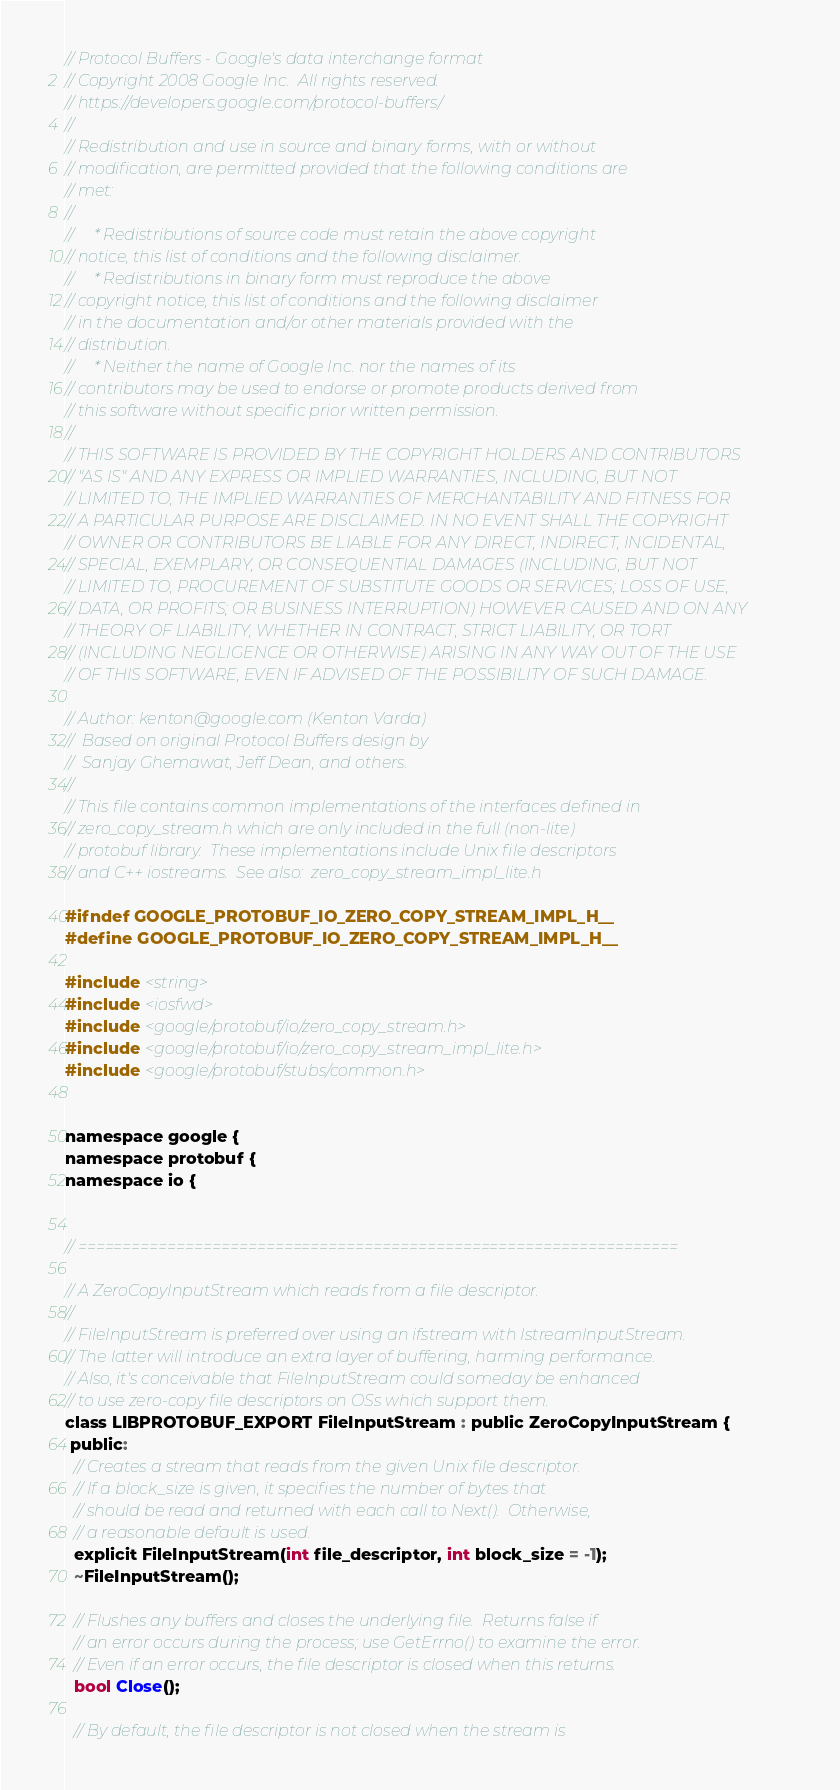<code> <loc_0><loc_0><loc_500><loc_500><_C_>// Protocol Buffers - Google's data interchange format
// Copyright 2008 Google Inc.  All rights reserved.
// https://developers.google.com/protocol-buffers/
//
// Redistribution and use in source and binary forms, with or without
// modification, are permitted provided that the following conditions are
// met:
//
//     * Redistributions of source code must retain the above copyright
// notice, this list of conditions and the following disclaimer.
//     * Redistributions in binary form must reproduce the above
// copyright notice, this list of conditions and the following disclaimer
// in the documentation and/or other materials provided with the
// distribution.
//     * Neither the name of Google Inc. nor the names of its
// contributors may be used to endorse or promote products derived from
// this software without specific prior written permission.
//
// THIS SOFTWARE IS PROVIDED BY THE COPYRIGHT HOLDERS AND CONTRIBUTORS
// "AS IS" AND ANY EXPRESS OR IMPLIED WARRANTIES, INCLUDING, BUT NOT
// LIMITED TO, THE IMPLIED WARRANTIES OF MERCHANTABILITY AND FITNESS FOR
// A PARTICULAR PURPOSE ARE DISCLAIMED. IN NO EVENT SHALL THE COPYRIGHT
// OWNER OR CONTRIBUTORS BE LIABLE FOR ANY DIRECT, INDIRECT, INCIDENTAL,
// SPECIAL, EXEMPLARY, OR CONSEQUENTIAL DAMAGES (INCLUDING, BUT NOT
// LIMITED TO, PROCUREMENT OF SUBSTITUTE GOODS OR SERVICES; LOSS OF USE,
// DATA, OR PROFITS; OR BUSINESS INTERRUPTION) HOWEVER CAUSED AND ON ANY
// THEORY OF LIABILITY, WHETHER IN CONTRACT, STRICT LIABILITY, OR TORT
// (INCLUDING NEGLIGENCE OR OTHERWISE) ARISING IN ANY WAY OUT OF THE USE
// OF THIS SOFTWARE, EVEN IF ADVISED OF THE POSSIBILITY OF SUCH DAMAGE.

// Author: kenton@google.com (Kenton Varda)
//  Based on original Protocol Buffers design by
//  Sanjay Ghemawat, Jeff Dean, and others.
//
// This file contains common implementations of the interfaces defined in
// zero_copy_stream.h which are only included in the full (non-lite)
// protobuf library.  These implementations include Unix file descriptors
// and C++ iostreams.  See also:  zero_copy_stream_impl_lite.h

#ifndef GOOGLE_PROTOBUF_IO_ZERO_COPY_STREAM_IMPL_H__
#define GOOGLE_PROTOBUF_IO_ZERO_COPY_STREAM_IMPL_H__

#include <string>
#include <iosfwd>
#include <google/protobuf/io/zero_copy_stream.h>
#include <google/protobuf/io/zero_copy_stream_impl_lite.h>
#include <google/protobuf/stubs/common.h>


namespace google {
namespace protobuf {
namespace io {


// ===================================================================

// A ZeroCopyInputStream which reads from a file descriptor.
//
// FileInputStream is preferred over using an ifstream with IstreamInputStream.
// The latter will introduce an extra layer of buffering, harming performance.
// Also, it's conceivable that FileInputStream could someday be enhanced
// to use zero-copy file descriptors on OSs which support them.
class LIBPROTOBUF_EXPORT FileInputStream : public ZeroCopyInputStream {
 public:
  // Creates a stream that reads from the given Unix file descriptor.
  // If a block_size is given, it specifies the number of bytes that
  // should be read and returned with each call to Next().  Otherwise,
  // a reasonable default is used.
  explicit FileInputStream(int file_descriptor, int block_size = -1);
  ~FileInputStream();

  // Flushes any buffers and closes the underlying file.  Returns false if
  // an error occurs during the process; use GetErrno() to examine the error.
  // Even if an error occurs, the file descriptor is closed when this returns.
  bool Close();

  // By default, the file descriptor is not closed when the stream is</code> 